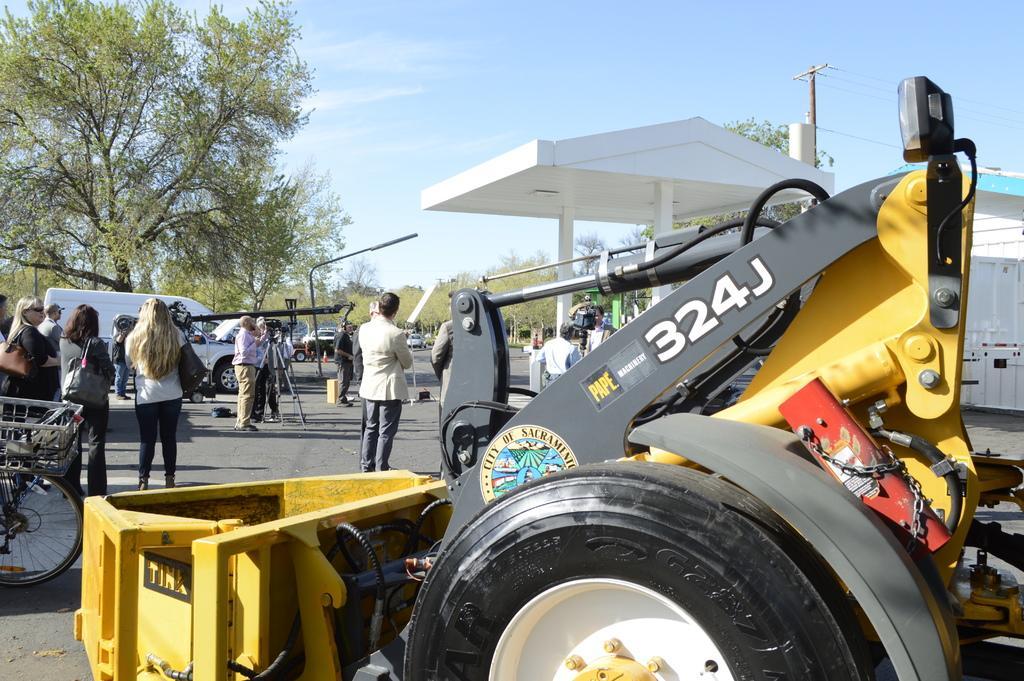Describe this image in one or two sentences. In this image we can see some people are standing and we can see some vehicles on the road. There is a structure with a roof and there are some trees and at the top we can see the sky. 